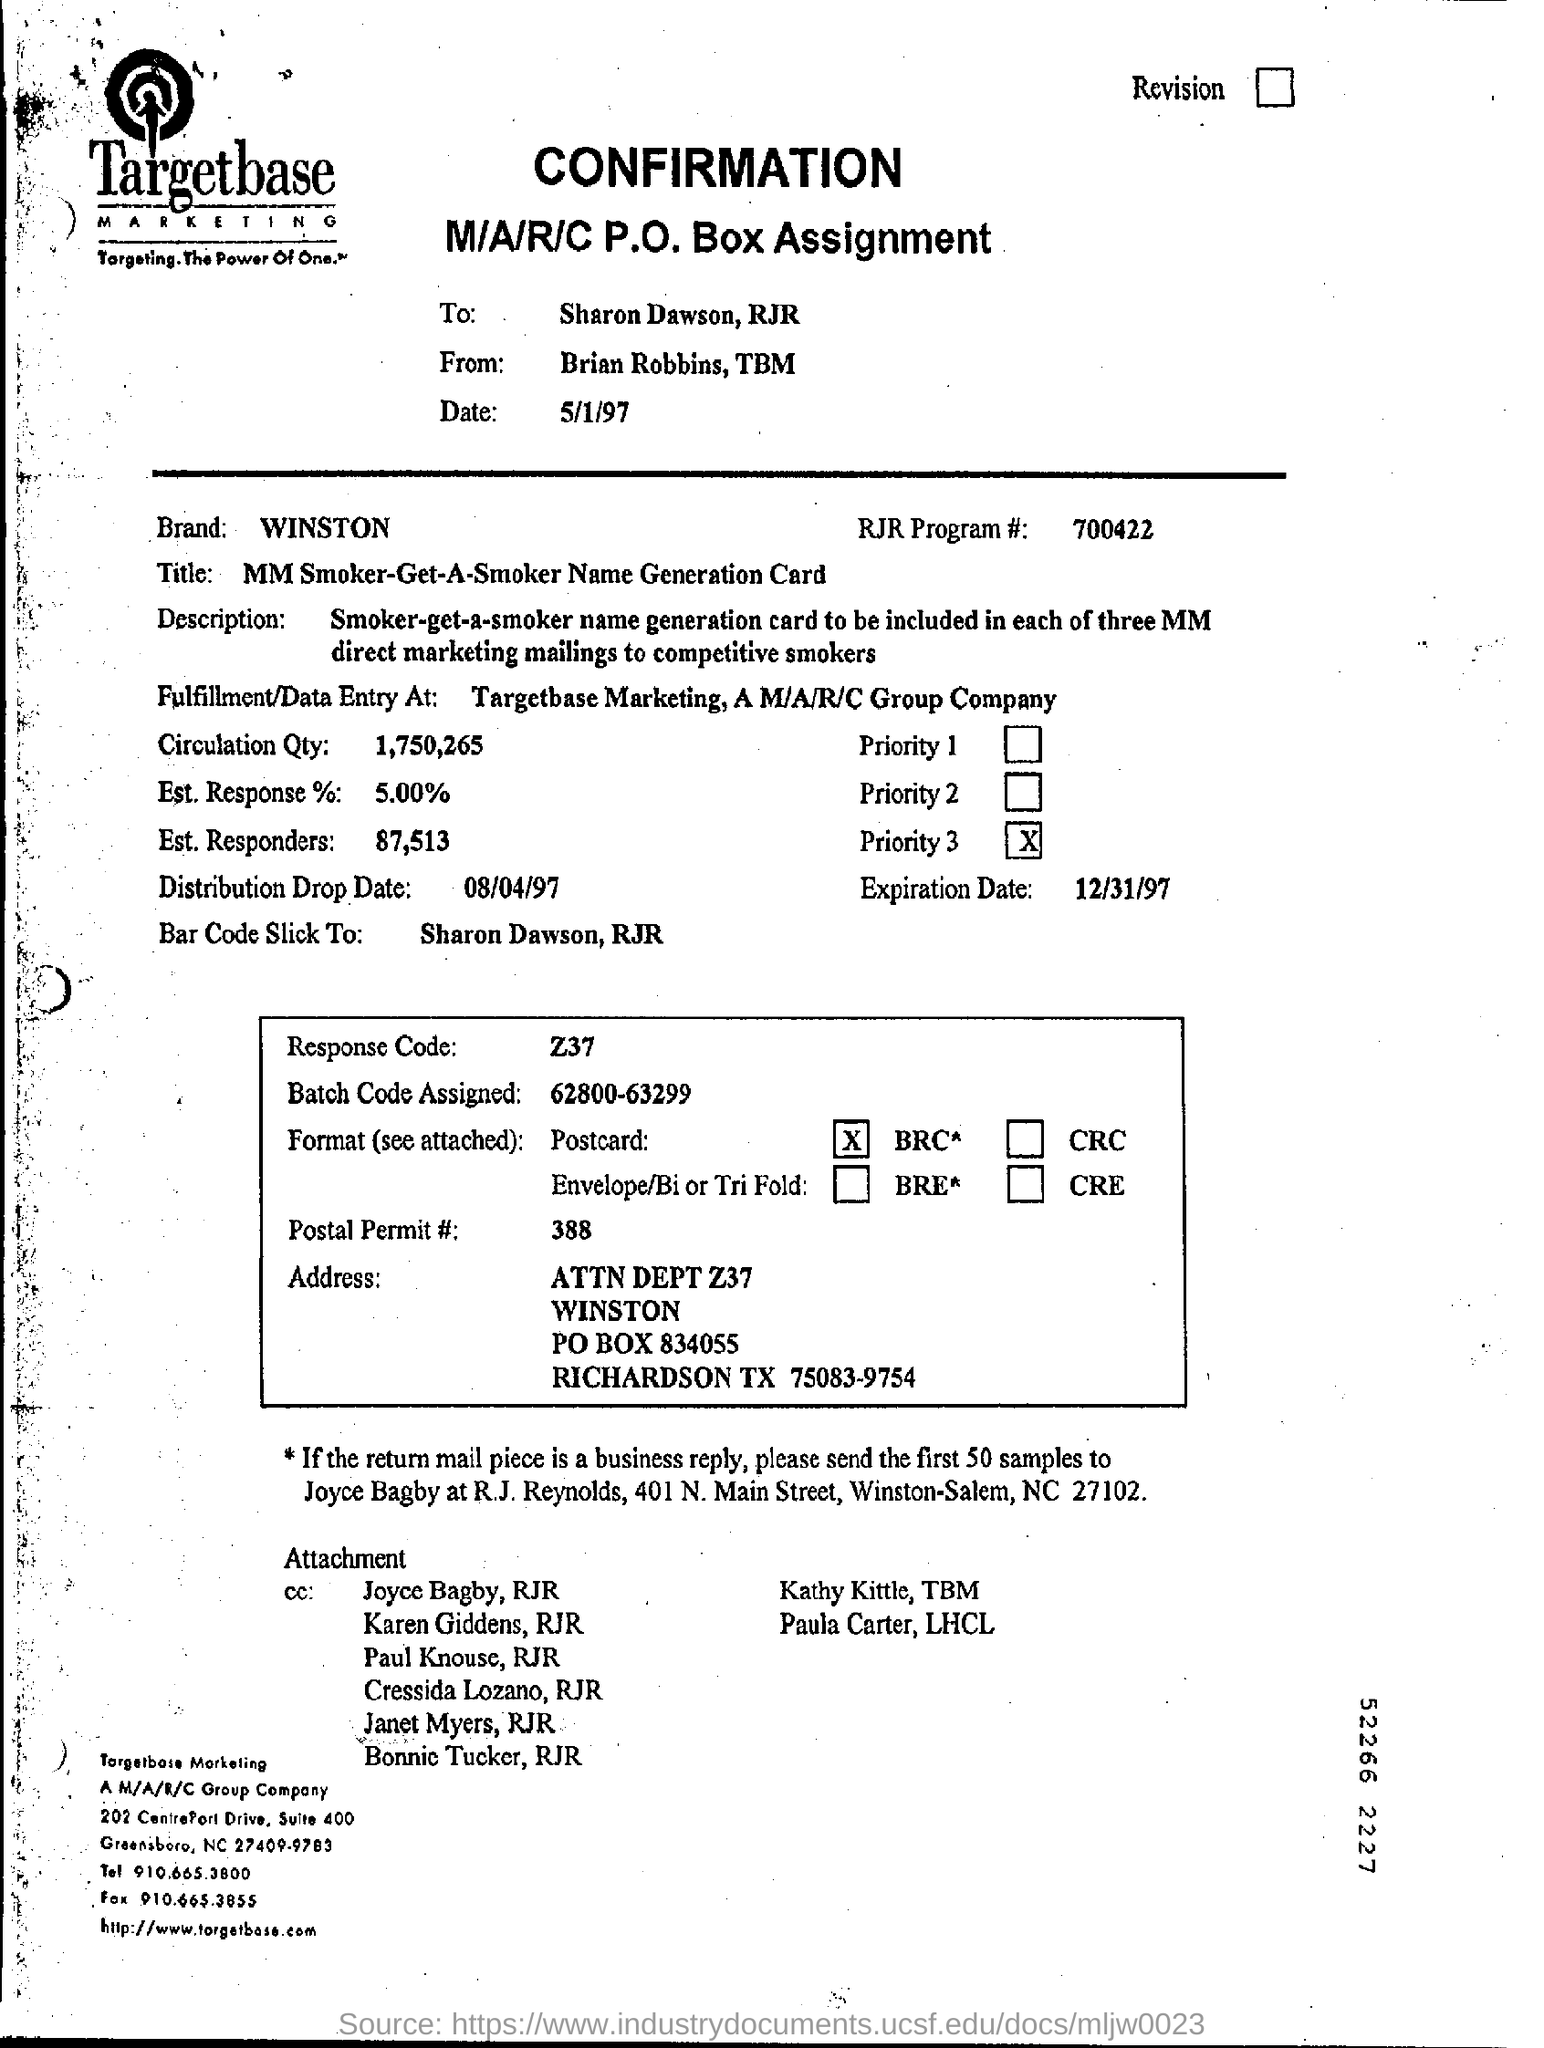What is the date mentioned at the top?
Provide a short and direct response. 5/1/97. 